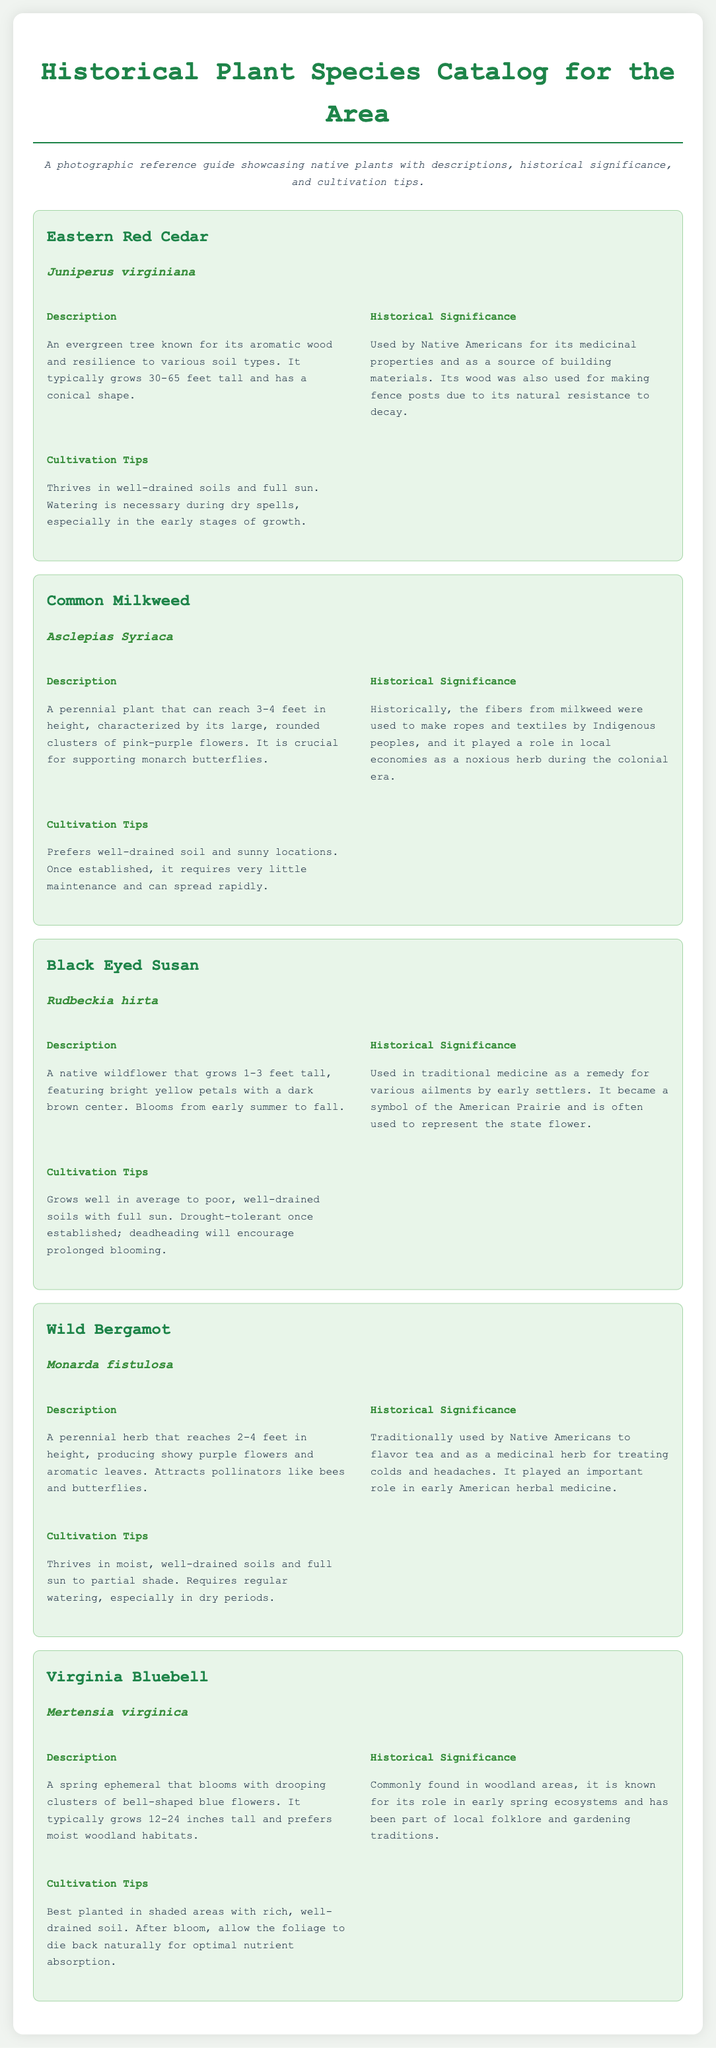What is the scientific name of Eastern Red Cedar? The scientific name is listed under the plant's title in the document.
Answer: Juniperus virginiana How tall does the Common Milkweed typically grow? The height of Common Milkweed is provided in the description section of the plant.
Answer: 3-4 feet What medicinal properties were attributed to Eastern Red Cedar? The historical significance section mentions its medicinal use by Native Americans.
Answer: Medicinal properties What is the main color of the blooms of Black Eyed Susan? The description specifies the color of the petals of Black Eyed Susan.
Answer: Yellow Which plant was used to make ropes and textiles by Indigenous peoples? The historical significance section identifies this use related to a specific plant.
Answer: Common Milkweed What type of soil does Wild Bergamot prefer? The cultivation tips specify soil preferences for Wild Bergamot.
Answer: Moist, well-drained soils What is the height range of Virginia Bluebell? The height of Virginia Bluebell is mentioned in the description.
Answer: 12-24 inches Which plant attracts monarch butterflies? The document states the importance of certain plants related to supporting specific pollinators.
Answer: Common Milkweed During which season does Virginia Bluebell bloom? The description for Virginia Bluebell gives insight into its blooming period.
Answer: Spring 